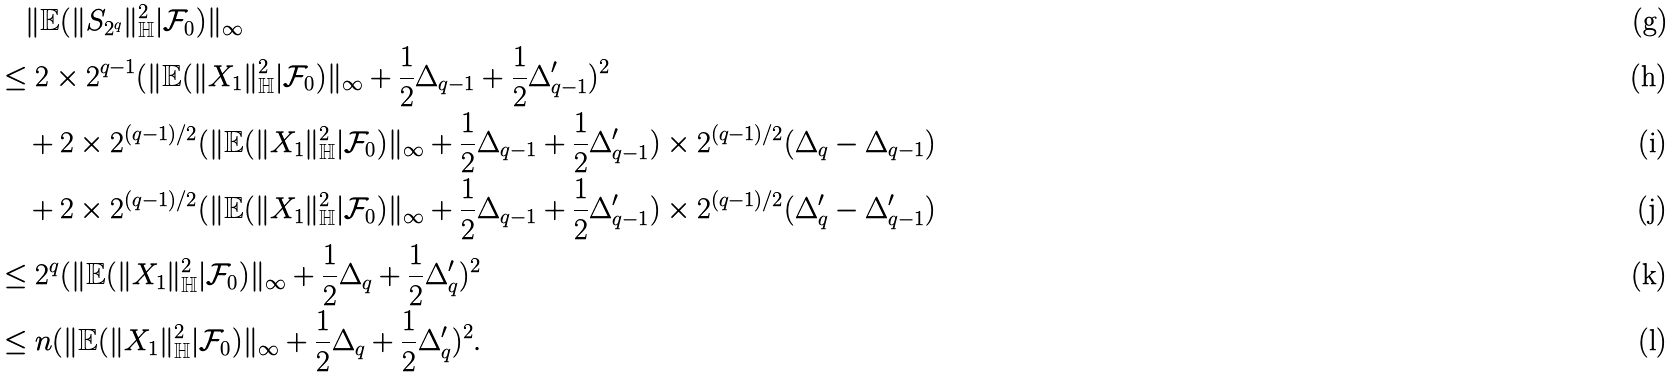Convert formula to latex. <formula><loc_0><loc_0><loc_500><loc_500>& \quad \| \mathbb { E } ( \| S _ { 2 ^ { q } } \| _ { \mathbb { H } } ^ { 2 } | \mathcal { F } _ { 0 } ) \| _ { \infty } & \\ & \leq 2 \times 2 ^ { q - 1 } ( \| \mathbb { E } ( \| X _ { 1 } \| _ { \mathbb { H } } ^ { 2 } | \mathcal { F } _ { 0 } ) \| _ { \infty } + \frac { 1 } { 2 } \Delta _ { q - 1 } + \frac { 1 } { 2 } \Delta ^ { \prime } _ { q - 1 } ) ^ { 2 } & \\ & \quad + 2 \times 2 ^ { ( q - 1 ) / 2 } ( \| \mathbb { E } ( \| X _ { 1 } \| _ { \mathbb { H } } ^ { 2 } | \mathcal { F } _ { 0 } ) \| _ { \infty } + \frac { 1 } { 2 } \Delta _ { q - 1 } + \frac { 1 } { 2 } \Delta ^ { \prime } _ { q - 1 } ) \times 2 ^ { ( q - 1 ) / 2 } ( \Delta _ { q } - \Delta _ { q - 1 } ) & \\ & \quad + 2 \times 2 ^ { ( q - 1 ) / 2 } ( \| \mathbb { E } ( \| X _ { 1 } \| _ { \mathbb { H } } ^ { 2 } | \mathcal { F } _ { 0 } ) \| _ { \infty } + \frac { 1 } { 2 } \Delta _ { q - 1 } + \frac { 1 } { 2 } \Delta ^ { \prime } _ { q - 1 } ) \times 2 ^ { ( q - 1 ) / 2 } ( \Delta ^ { \prime } _ { q } - \Delta ^ { \prime } _ { q - 1 } ) & \\ & \leq 2 ^ { q } ( \| \mathbb { E } ( \| X _ { 1 } \| _ { \mathbb { H } } ^ { 2 } | \mathcal { F } _ { 0 } ) \| _ { \infty } + \frac { 1 } { 2 } \Delta _ { q } + \frac { 1 } { 2 } \Delta ^ { \prime } _ { q } ) ^ { 2 } & \\ & \leq n ( \| \mathbb { E } ( \| X _ { 1 } \| _ { \mathbb { H } } ^ { 2 } | \mathcal { F } _ { 0 } ) \| _ { \infty } + \frac { 1 } { 2 } \Delta _ { q } + \frac { 1 } { 2 } \Delta ^ { \prime } _ { q } ) ^ { 2 } . &</formula> 